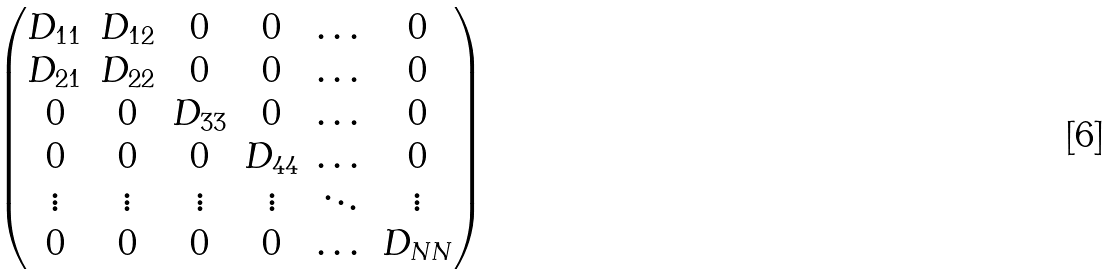<formula> <loc_0><loc_0><loc_500><loc_500>\begin{pmatrix} D _ { 1 1 } & D _ { 1 2 } & 0 & 0 & \dots & 0 \\ D _ { 2 1 } & D _ { 2 2 } & 0 & 0 & \dots & 0 \\ 0 & 0 & D _ { 3 3 } & 0 & \dots & 0 \\ 0 & 0 & 0 & D _ { 4 4 } & \dots & 0 \\ \vdots & \vdots & \vdots & \vdots & \ddots & \vdots \\ 0 & 0 & 0 & 0 & \dots & D _ { N N } \\ \end{pmatrix}</formula> 